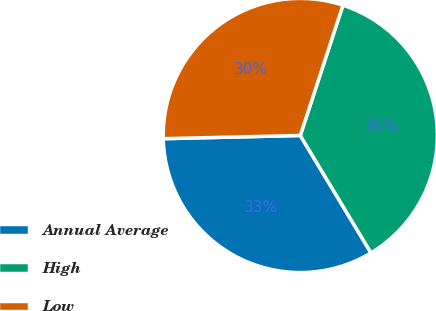Convert chart. <chart><loc_0><loc_0><loc_500><loc_500><pie_chart><fcel>Annual Average<fcel>High<fcel>Low<nl><fcel>33.25%<fcel>36.34%<fcel>30.4%<nl></chart> 